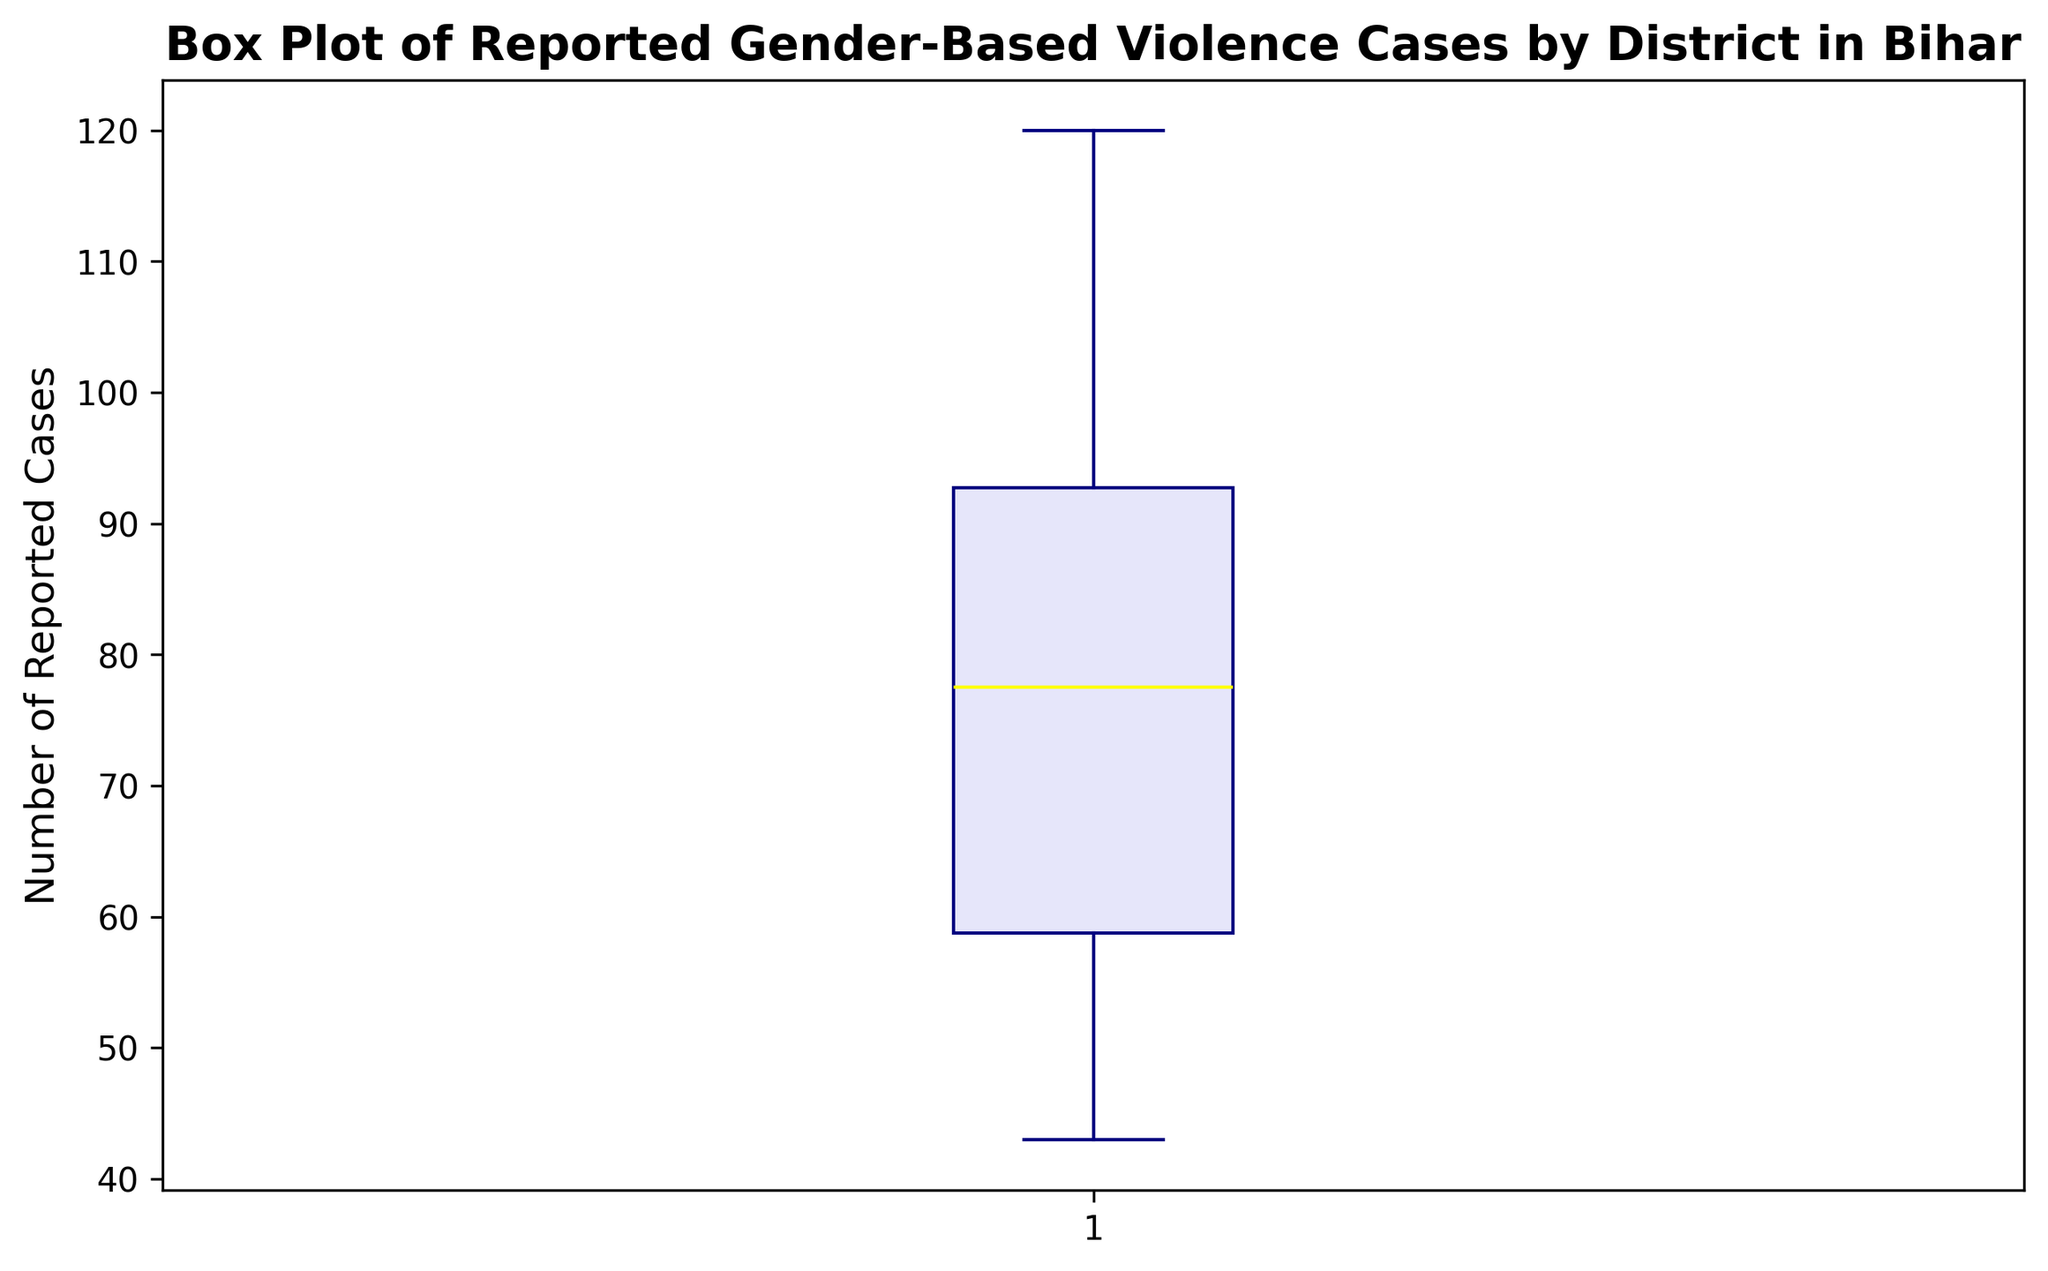What is the median number of reported gender-based violence cases by district in Bihar? The median is the middle value when the data points are arranged in ascending order. Visually, in a box plot, the median is represented by a line inside the box.
Answer: Around 79 cases Which districts have reported cases that lie outside the whiskers of the box plot? Data points outside the whiskers are considered outliers. In the plot, these would be marked by distinct o markers.
Answer: Bhagalpur and Patna What is the interquartile range (IQR) for reported gender-based violence cases? The IQR is the difference between the upper quartile (Q3) and the lower quartile (Q1). In the box plot, Q1 and Q3 are represented by the edges of the box.
Answer: Approximately 38 cases How does the median number of reported cases compare to the average number of reported cases? The median is around 79, as derived directly from the plot. To find the average, sum all the reported cases and divide by the number of districts.
Answer: Median: 79, Average: Around 76 Are there more districts with reported cases above the median or below the median? The median divides the data into two equal halves. The number of districts above and below the median should each be approximately half, unless some values are exactly the median.
Answer: Roughly equal What is the range of the reported gender-based violence cases? The range is the difference between the maximum and minimum reported cases. This can be observed from the whiskers of the box plot.
Answer: 77 cases Which district corresponds to the highest outlier and how many cases were reported in that district? The highest outlier would be marked distinctly outside the whiskers at the upper end of the plot.
Answer: Patna, 120 cases How do reported cases for the district of Araria compare to the median? Locate Araria’s reported cases and compare that value with the median line in the box plot.
Answer: Slightly above the median Are the number of reported cases for Patna significantly higher than the upper quartile (Q3)? Compare Patna's reported cases with the upper quartile value. Since it's marked as an outlier, it should be significantly higher.
Answer: Yes How do reported cases for districts above the upper quartile compare in terms of variation? The points above the upper quartile would be a few outliers. Observe their distribution to understand the variation.
Answer: High variation, especially for Patna and Bhagalpur 